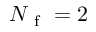Convert formula to latex. <formula><loc_0><loc_0><loc_500><loc_500>N _ { f } = 2</formula> 